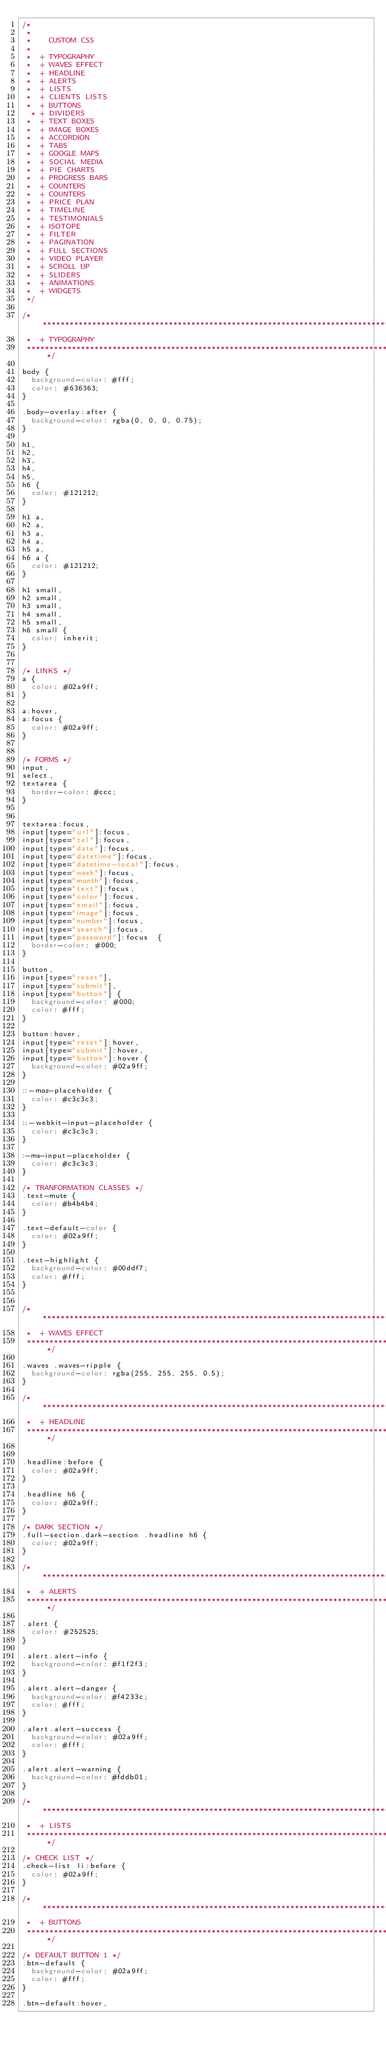<code> <loc_0><loc_0><loc_500><loc_500><_CSS_>/*
 *
 *		CUSTOM.CSS
 *
 *	+ TYPOGRAPHY
 *	+ WAVES EFFECT
 * 	+ HEADLINE
 *	+ ALERTS
 *	+ LISTS
 *	+ CLIENTS LISTS
 *	+ BUTTONS
  *	+ DIVIDERS
 *	+ TEXT BOXES
 *	+ IMAGE BOXES
 *	+ ACCORDION
 * 	+ TABS
 *	+ GOOGLE MAPS
 * 	+ SOCIAL MEDIA
 *	+ PIE CHARTS
 *	+ PROGRESS BARS
 * 	+ COUNTERS
 * 	+ COUNTERS
 *	+ PRICE PLAN
 *	+ TIMELINE
 * 	+ TESTIMONIALS
 * 	+ ISOTOPE
 * 	+ FILTER
 * 	+ PAGINATION
 * 	+ FULL SECTIONS
 * 	+ VIDEO PLAYER
 * 	+ SCROLL UP
 *	+ SLIDERS
 *	+ ANIMATIONS
 *	+ WIDGETS
 */

/***********************************************************************************
 *	+ TYPOGRAPHY
 ***********************************************************************************/

body {
	background-color: #fff;
	color: #636363;
}

.body-overlay:after {
	background-color: rgba(0, 0, 0, 0.75);
}

h1,
h2,
h3,
h4,
h5,
h6 {
	color: #121212;
}

h1 a,
h2 a,
h3 a,
h4 a,
h5 a,
h6 a {
	color: #121212;
}

h1 small,
h2 small,
h3 small,
h4 small,
h5 small,
h6 small {
	color: inherit;
}


/* LINKS */
a {
	color: #02a9ff;
}

a:hover,
a:focus {
	color: #02a9ff;
}


/* FORMS */
input,
select,
textarea {
	border-color: #ccc;
}


textarea:focus,
input[type="url"]:focus,
input[type="tel"]:focus,
input[type="date"]:focus,
input[type="datetime"]:focus,
input[type="datetime-local"]:focus,
input[type="week"]:focus,
input[type="month"]:focus,
input[type="text"]:focus,
input[type="color"]:focus,
input[type="email"]:focus,
input[type="image"]:focus,
input[type="number"]:focus,
input[type="search"]:focus,
input[type="password"]:focus	{
	border-color: #000;
}

button,
input[type="reset"],
input[type="submit"],
input[type="button"] {
	background-color: #000;
	color: #fff;
}

button:hover,
input[type="reset"]:hover,
input[type="submit"]:hover,
input[type="button"]:hover {
	background-color: #02a9ff;
}

::-moz-placeholder {
	color: #c3c3c3;
}

::-webkit-input-placeholder {
	color: #c3c3c3;
}

:-ms-input-placeholder {
	color: #c3c3c3;
}

/* TRANFORMATION CLASSES */
.text-mute {
	color: #b4b4b4;
}

.text-default-color {
	color: #02a9ff;
}

.text-highlight {
	background-color: #00ddf7;
	color: #fff;
}


/***********************************************************************************
 *	+ WAVES EFFECT
 ***********************************************************************************/

.waves .waves-ripple {
	background-color: rgba(255, 255, 255, 0.5);
}

/***********************************************************************************
 *	+ HEADLINE
 ***********************************************************************************/


.headline:before {
	color: #02a9ff;
}

.headline h6 {
	color: #02a9ff;
}

/* DARK SECTION */
.full-section.dark-section .headline h6 {
	color: #02a9ff;
}

/***********************************************************************************
 *	+ ALERTS
 ***********************************************************************************/

.alert {
	color: #252525;
}

.alert.alert-info {
	background-color: #f1f2f3;
}

.alert.alert-danger {
	background-color: #f4233c;
	color: #fff;
}

.alert.alert-success {
	background-color: #02a9ff;
	color: #fff;
}

.alert.alert-warning {
	background-color: #fddb01;
}

/***********************************************************************************
 *	+ LISTS
 ***********************************************************************************/

/* CHECK LIST */
.check-list li:before {
	color: #02a9ff;
}

/***********************************************************************************
 *	+ BUTTONS
 ***********************************************************************************/

/* DEFAULT BUTTON 1 */
.btn-default {
	background-color: #02a9ff;
	color: #fff;
}

.btn-default:hover,</code> 